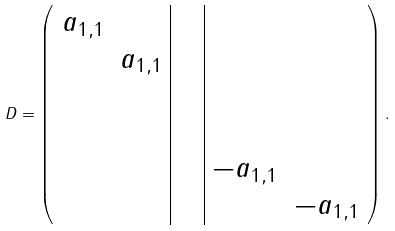<formula> <loc_0><loc_0><loc_500><loc_500>D = \left ( \begin{array} { c c | c c | c c } a _ { 1 , 1 } & & & & & \\ & a _ { 1 , 1 } & & & & \\ & & & & & \\ & & & & & \\ & & & & - a _ { 1 , 1 } & \\ & & & & & - a _ { 1 , 1 } \\ \end{array} \right ) .</formula> 